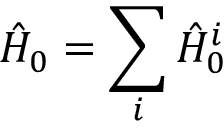Convert formula to latex. <formula><loc_0><loc_0><loc_500><loc_500>\hat { H } _ { 0 } = \sum _ { i } \hat { H } _ { 0 } ^ { i }</formula> 